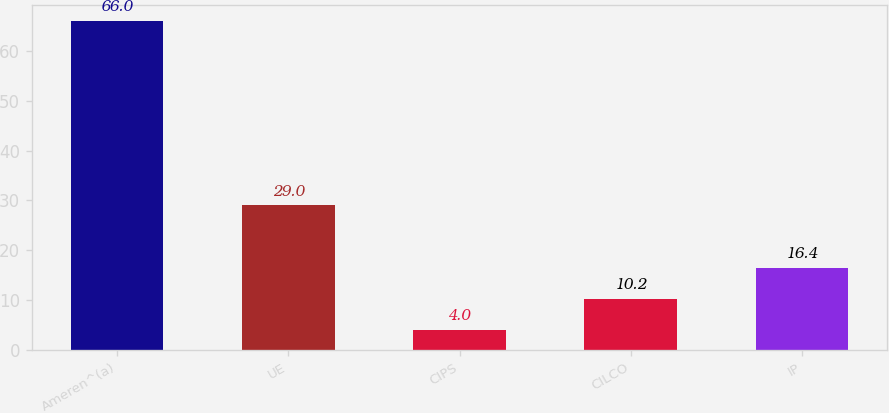Convert chart. <chart><loc_0><loc_0><loc_500><loc_500><bar_chart><fcel>Ameren^(a)<fcel>UE<fcel>CIPS<fcel>CILCO<fcel>IP<nl><fcel>66<fcel>29<fcel>4<fcel>10.2<fcel>16.4<nl></chart> 